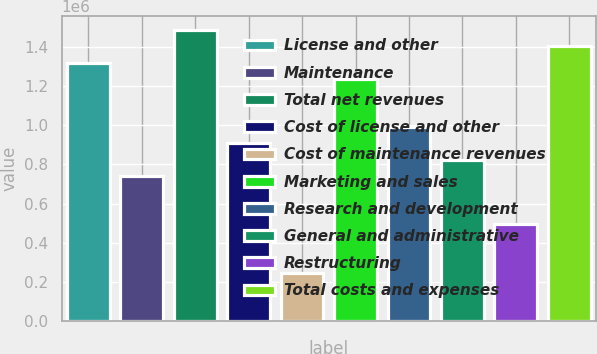Convert chart to OTSL. <chart><loc_0><loc_0><loc_500><loc_500><bar_chart><fcel>License and other<fcel>Maintenance<fcel>Total net revenues<fcel>Cost of license and other<fcel>Cost of maintenance revenues<fcel>Marketing and sales<fcel>Research and development<fcel>General and administrative<fcel>Restructuring<fcel>Total costs and expenses<nl><fcel>1.31991e+06<fcel>742451<fcel>1.4849e+06<fcel>907440<fcel>247484<fcel>1.23742e+06<fcel>989934<fcel>824945<fcel>494967<fcel>1.40241e+06<nl></chart> 